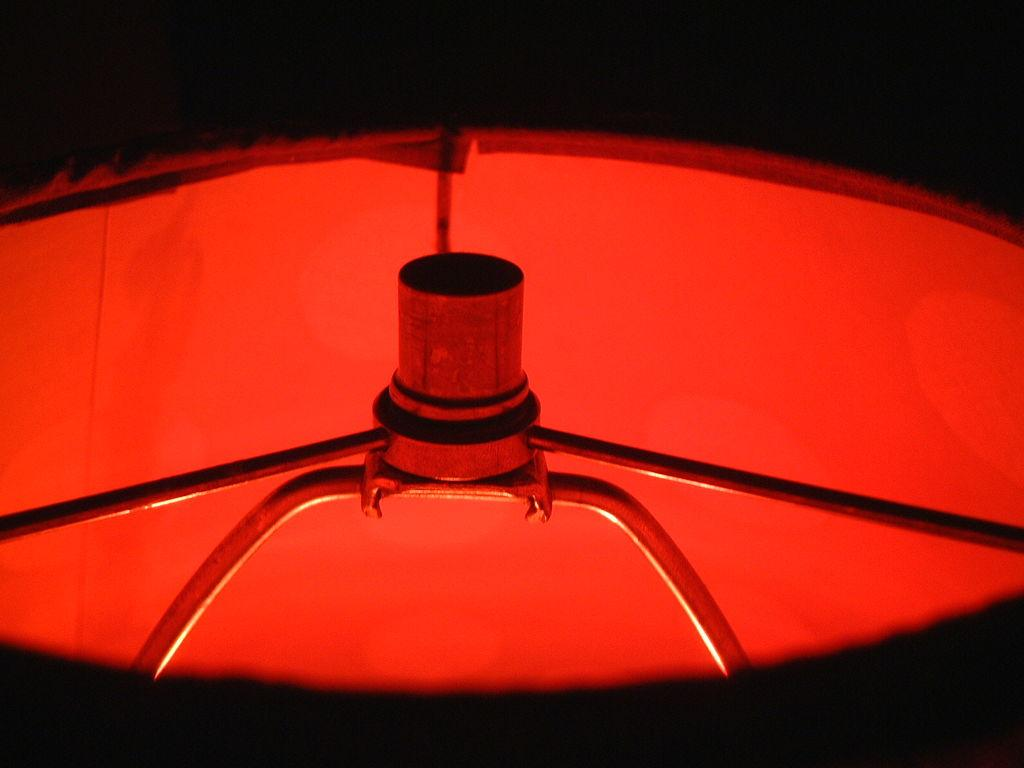What is the main subject in the middle of the image? There is a metal object in the middle of the image. What is covering or surrounding the metal object? There is a red color object, possibly a cloth, surrounding the metal object. What is the color of the background in the image? The background of the image is black. What type of boot is visible on the metal object in the image? There is no boot present in the image; it features a metal object surrounded by a red color object, possibly a cloth. What kind of haircut does the metal object have in the image? The metal object does not have a haircut, as it is an inanimate object. 